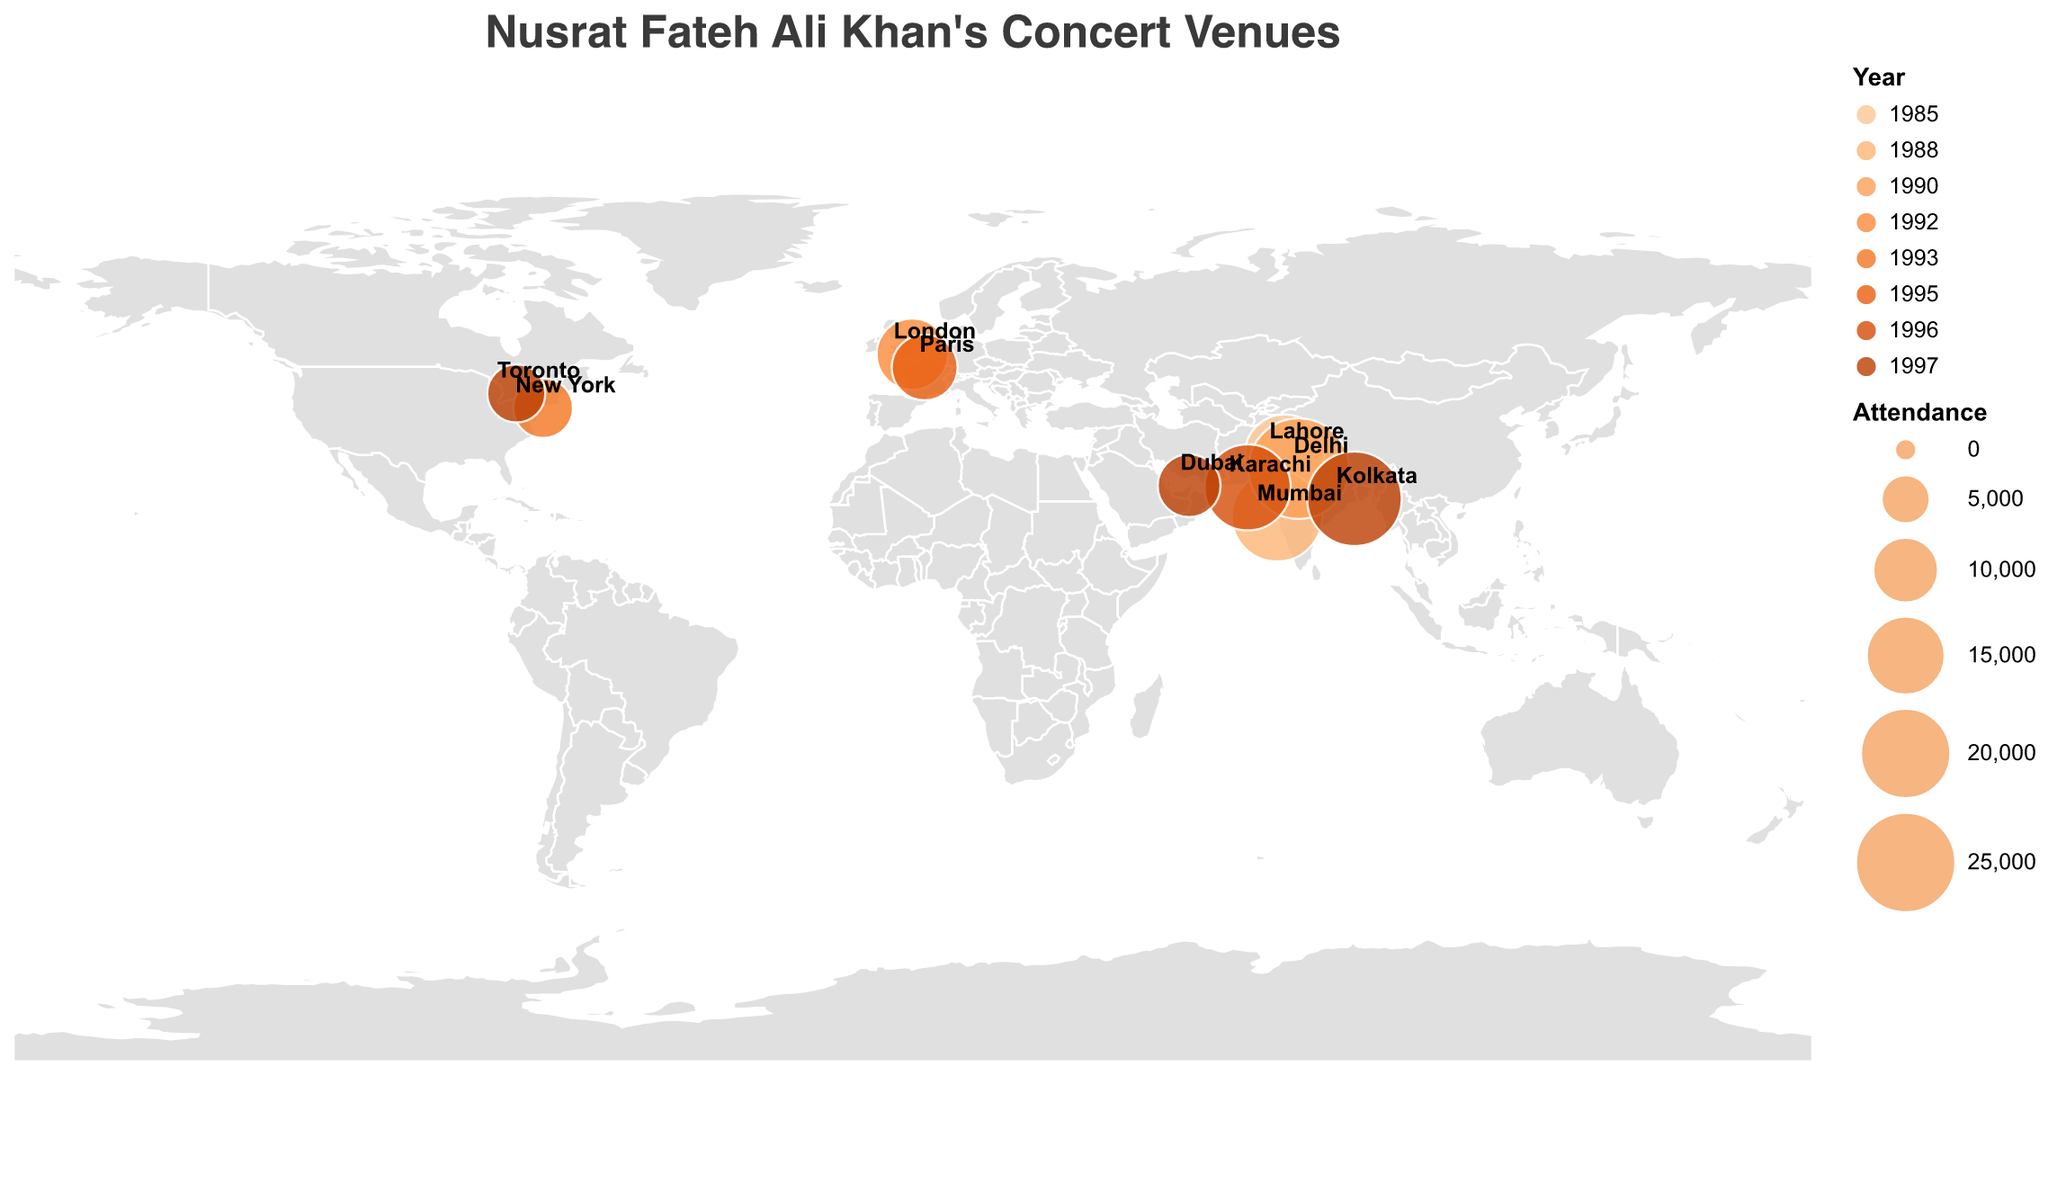What is the city with the highest concert attendance? The city with the highest attendance is indicated by the largest circle on the map. Based on the given data, Delhi, India has the highest attendance of 25,000 people.
Answer: Delhi, 25,000 Which cities in India did Nusrat Fateh Ali Khan perform in? By looking at the labeled cities on the map, the cities in India where he performed are Mumbai, Delhi, and Kolkata.
Answer: Mumbai, Delhi, Kolkata In which year did Nusrat Fateh Ali Khan perform in Karachi? The concert in Karachi is indicated on the map as one of the smaller circles in Pakistan. The tooltip information or legend reveals that he performed there in 1996.
Answer: 1996 Compare the attendance figures for concerts held in Lahore and Karachi. Lahore has an attendance of 15,000, while Karachi has an attendance of 18,000. Thus, Karachi’s attendance figure is higher.
Answer: Karachi How do the European concert attendance figures compare to those in North America? The European concerts (London in 1992 with 12,000 attendees, and Paris in 1995 with 10,000 attendees) compared to North American concerts (New York in 1993 with 8,000 attendees, and Toronto in 1997 with 7,500 attendees) show that European concerts generally had higher attendance figures than those in North America.
Answer: European concerts had higher attendance What is the average attendance figure for his concerts in India? Adding up the attendance figures for Mumbai (20,000), Delhi (25,000), and Kolkata (22,000) equals 67,000. Dividing by the number of concerts (3) gives an average of 22,333.
Answer: 22,333 What was the easternmost city Nusrat Fateh Ali Khan performed in? By examining the map for the farthest right point, Kolkata, India, is the easternmost city he performed in.
Answer: Kolkata Which year had the highest concert attendance and what was the city? The largest circle corresponds to Delhi in 1990, with an attendance of 25,000.
Answer: 1990, Delhi Describe the trend in Nusrat Fateh Ali Khan’s concert venues from the mid-1980s to late 1990s. Starting from Pakistan (Lahore in 1985) to a broader international reach over time, including India, UK, USA, France, UAE, and Canada, with varying attendance numbers indicating growing international appeal.
Answer: Increasingly international What was the smallest concert attendance figure and where did it take place? By looking at the smallest circles on the map and checking their tooltips, the smallest attendance was in Toronto, Canada, with 7,500 attendees in 1997.
Answer: Toronto, 7,500 